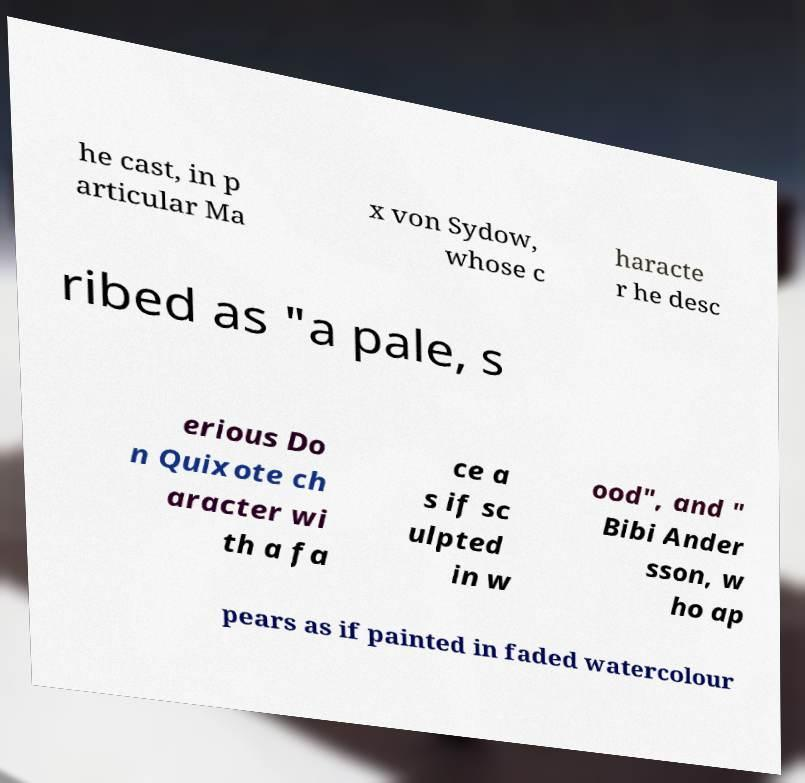Please read and relay the text visible in this image. What does it say? he cast, in p articular Ma x von Sydow, whose c haracte r he desc ribed as "a pale, s erious Do n Quixote ch aracter wi th a fa ce a s if sc ulpted in w ood", and " Bibi Ander sson, w ho ap pears as if painted in faded watercolour 